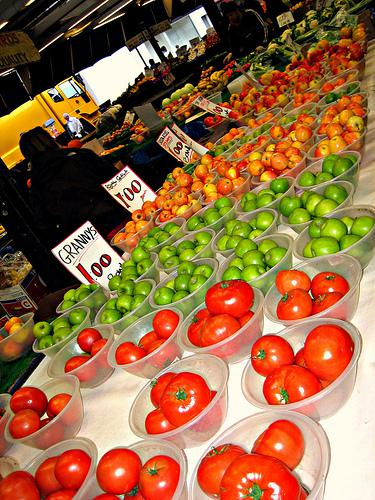Question: what are three fruits?
Choices:
A. Bananas.
B. Oranges.
C. Pineapple.
D. Apples.
Answer with the letter. Answer: D Question: who is picking fruits at far end?
Choices:
A. The woman.
B. The farmer.
C. A man.
D. The child.
Answer with the letter. Answer: C Question: when was picture taken?
Choices:
A. At night.
B. During the day.
C. In the morning.
D. In the afternoon.
Answer with the letter. Answer: B Question: how many tomato are packed in one bowl?
Choices:
A. Four.
B. Three.
C. Five.
D. Seven.
Answer with the letter. Answer: A Question: why are they displayed?
Choices:
A. They're pretty.
B. As decoration.
C. To trade.
D. For sale.
Answer with the letter. Answer: D Question: what is the price tag of granny?
Choices:
A. 100.
B. 150.
C. 200.
D. 25.
Answer with the letter. Answer: A 